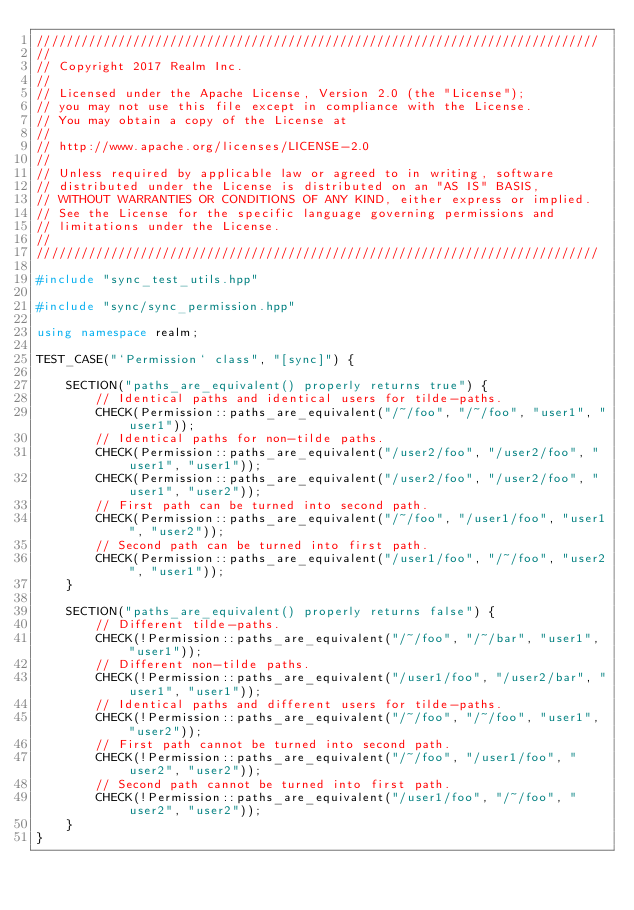Convert code to text. <code><loc_0><loc_0><loc_500><loc_500><_C++_>////////////////////////////////////////////////////////////////////////////
//
// Copyright 2017 Realm Inc.
//
// Licensed under the Apache License, Version 2.0 (the "License");
// you may not use this file except in compliance with the License.
// You may obtain a copy of the License at
//
// http://www.apache.org/licenses/LICENSE-2.0
//
// Unless required by applicable law or agreed to in writing, software
// distributed under the License is distributed on an "AS IS" BASIS,
// WITHOUT WARRANTIES OR CONDITIONS OF ANY KIND, either express or implied.
// See the License for the specific language governing permissions and
// limitations under the License.
//
////////////////////////////////////////////////////////////////////////////

#include "sync_test_utils.hpp"

#include "sync/sync_permission.hpp"

using namespace realm;

TEST_CASE("`Permission` class", "[sync]") {

	SECTION("paths_are_equivalent() properly returns true") {
		// Identical paths and identical users for tilde-paths.
		CHECK(Permission::paths_are_equivalent("/~/foo", "/~/foo", "user1", "user1"));
		// Identical paths for non-tilde paths.
		CHECK(Permission::paths_are_equivalent("/user2/foo", "/user2/foo", "user1", "user1"));
		CHECK(Permission::paths_are_equivalent("/user2/foo", "/user2/foo", "user1", "user2"));
		// First path can be turned into second path.
		CHECK(Permission::paths_are_equivalent("/~/foo", "/user1/foo", "user1", "user2"));
		// Second path can be turned into first path.
		CHECK(Permission::paths_are_equivalent("/user1/foo", "/~/foo", "user2", "user1"));
	}

	SECTION("paths_are_equivalent() properly returns false") {
		// Different tilde-paths.
		CHECK(!Permission::paths_are_equivalent("/~/foo", "/~/bar", "user1", "user1"));
		// Different non-tilde paths.
		CHECK(!Permission::paths_are_equivalent("/user1/foo", "/user2/bar", "user1", "user1"));
		// Identical paths and different users for tilde-paths. 
		CHECK(!Permission::paths_are_equivalent("/~/foo", "/~/foo", "user1", "user2"));
		// First path cannot be turned into second path.
		CHECK(!Permission::paths_are_equivalent("/~/foo", "/user1/foo", "user2", "user2"));
		// Second path cannot be turned into first path.
		CHECK(!Permission::paths_are_equivalent("/user1/foo", "/~/foo", "user2", "user2"));
	}
}
</code> 